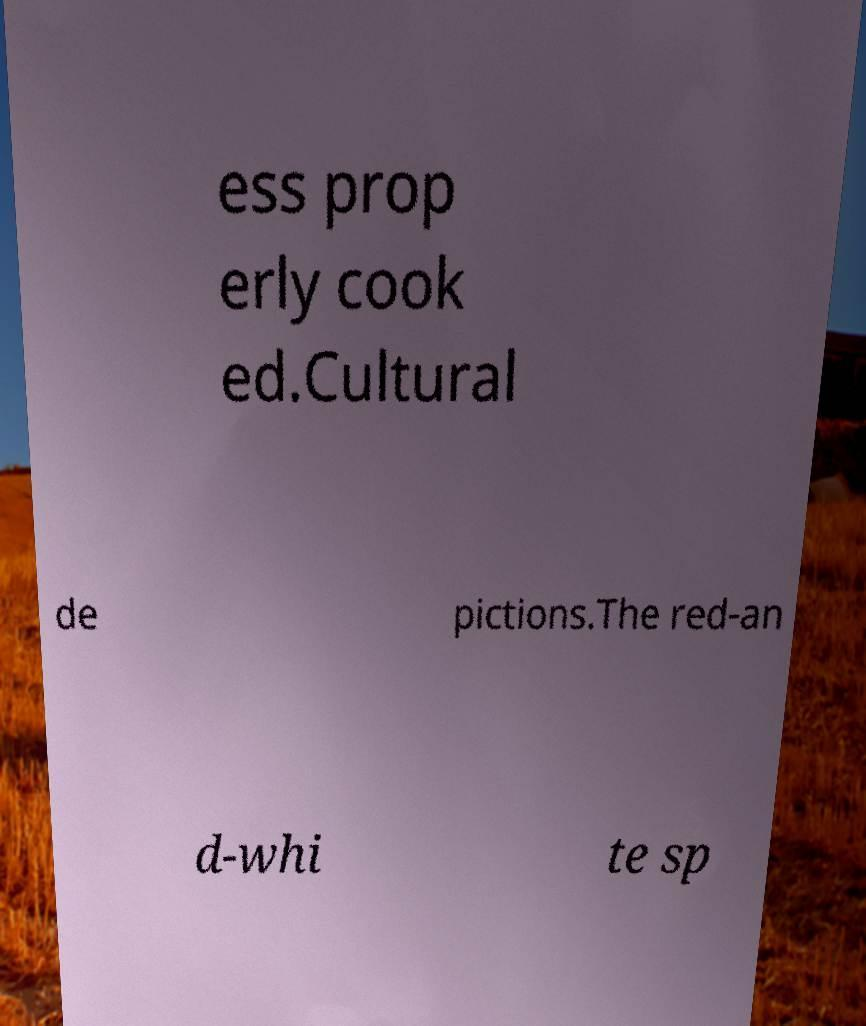Please read and relay the text visible in this image. What does it say? ess prop erly cook ed.Cultural de pictions.The red-an d-whi te sp 